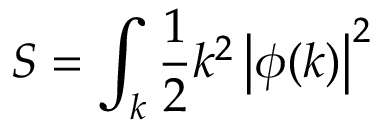<formula> <loc_0><loc_0><loc_500><loc_500>S = \int _ { k } { \frac { 1 } { 2 } } k ^ { 2 } \left | \phi ( k ) \right | ^ { 2 }</formula> 